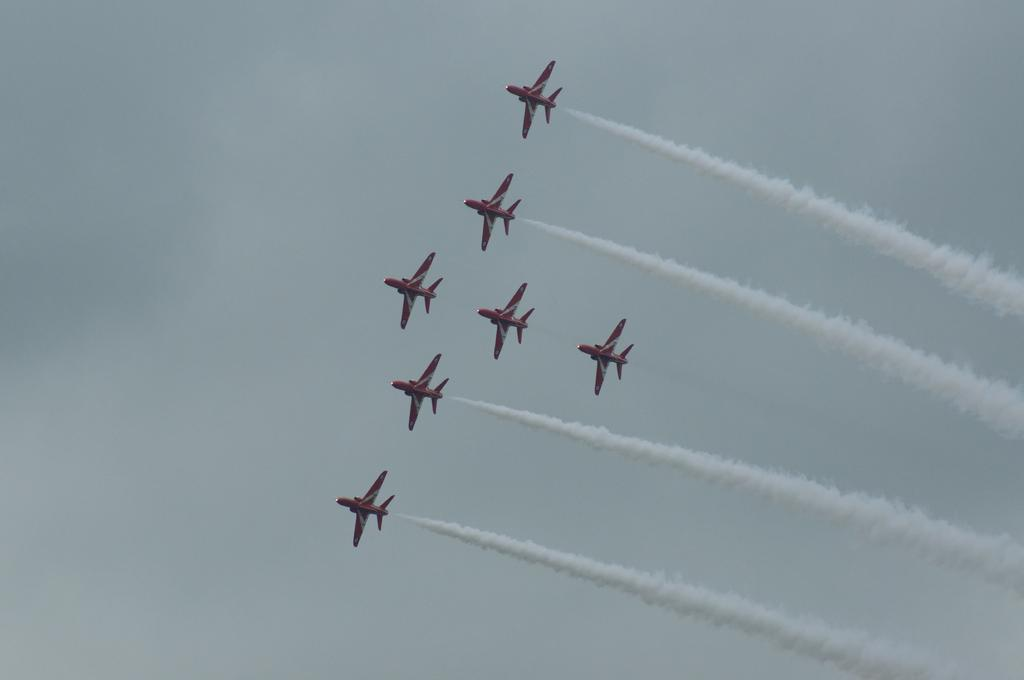What event is taking place in the picture? There is an Airshow in the picture. How many airplanes can be seen flying in the sky? There are seven airplanes flying in the sky. What type of fowl can be seen flying alongside the airplanes in the image? There are no fowl present in the image; only airplanes can be seen flying in the sky. 